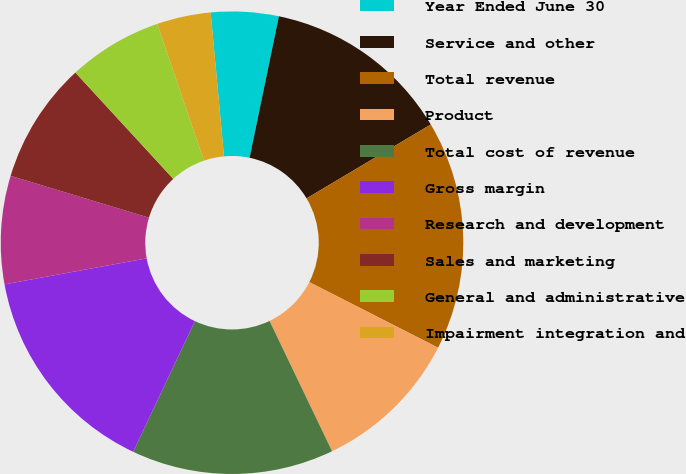Convert chart to OTSL. <chart><loc_0><loc_0><loc_500><loc_500><pie_chart><fcel>Year Ended June 30<fcel>Service and other<fcel>Total revenue<fcel>Product<fcel>Total cost of revenue<fcel>Gross margin<fcel>Research and development<fcel>Sales and marketing<fcel>General and administrative<fcel>Impairment integration and<nl><fcel>4.72%<fcel>13.21%<fcel>16.04%<fcel>10.38%<fcel>14.15%<fcel>15.09%<fcel>7.55%<fcel>8.49%<fcel>6.6%<fcel>3.77%<nl></chart> 